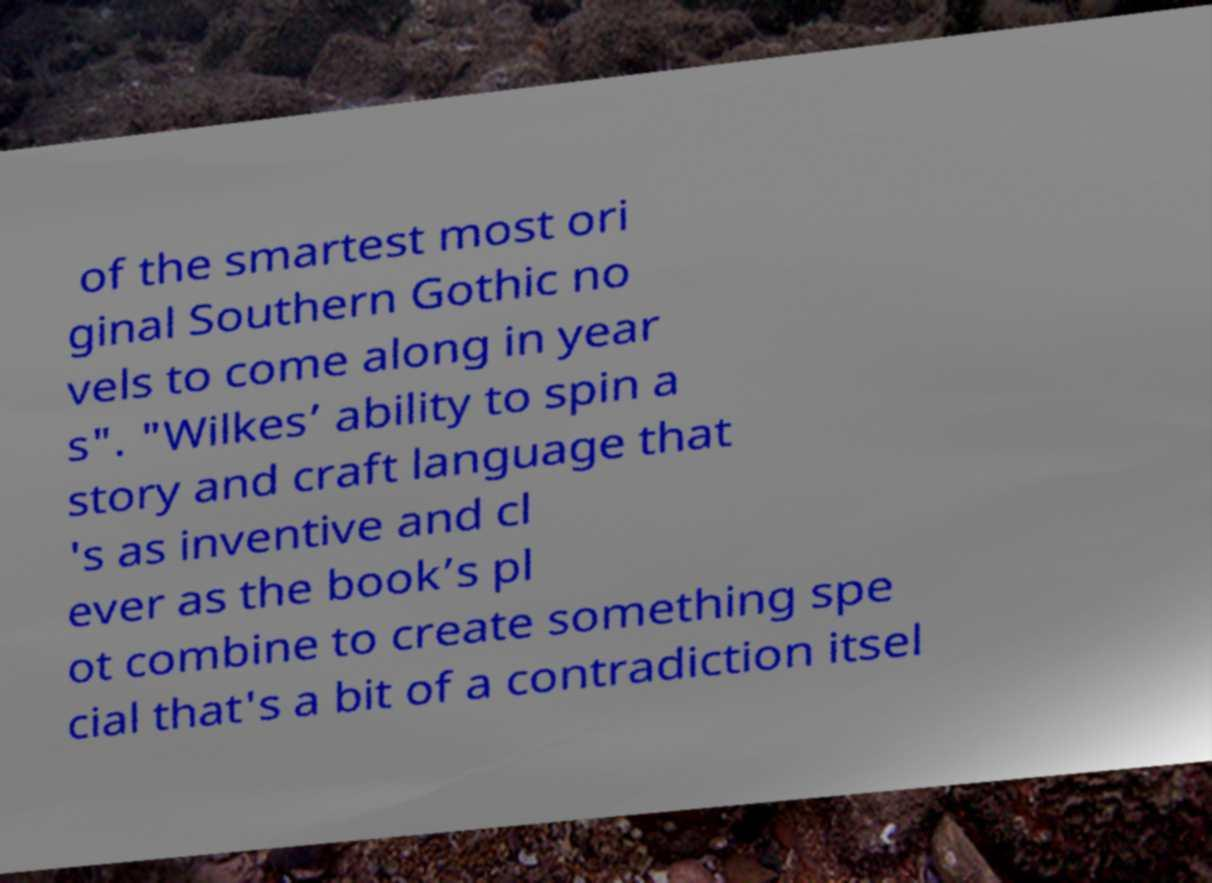Could you assist in decoding the text presented in this image and type it out clearly? of the smartest most ori ginal Southern Gothic no vels to come along in year s". "Wilkes’ ability to spin a story and craft language that 's as inventive and cl ever as the book’s pl ot combine to create something spe cial that's a bit of a contradiction itsel 